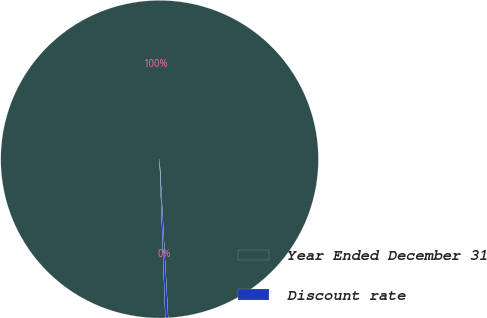<chart> <loc_0><loc_0><loc_500><loc_500><pie_chart><fcel>Year Ended December 31<fcel>Discount rate<nl><fcel>99.72%<fcel>0.28%<nl></chart> 